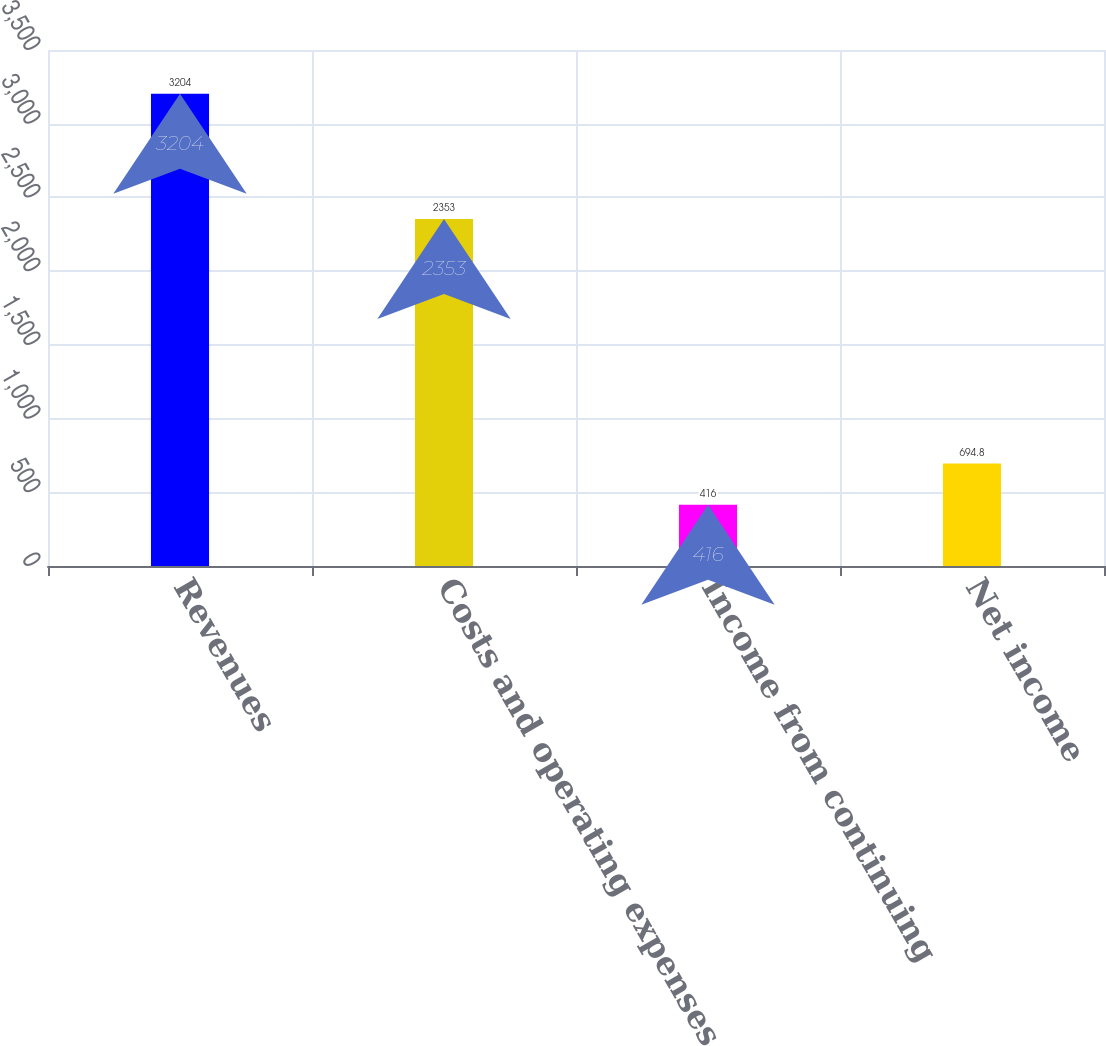Convert chart. <chart><loc_0><loc_0><loc_500><loc_500><bar_chart><fcel>Revenues<fcel>Costs and operating expenses<fcel>Income from continuing<fcel>Net income<nl><fcel>3204<fcel>2353<fcel>416<fcel>694.8<nl></chart> 